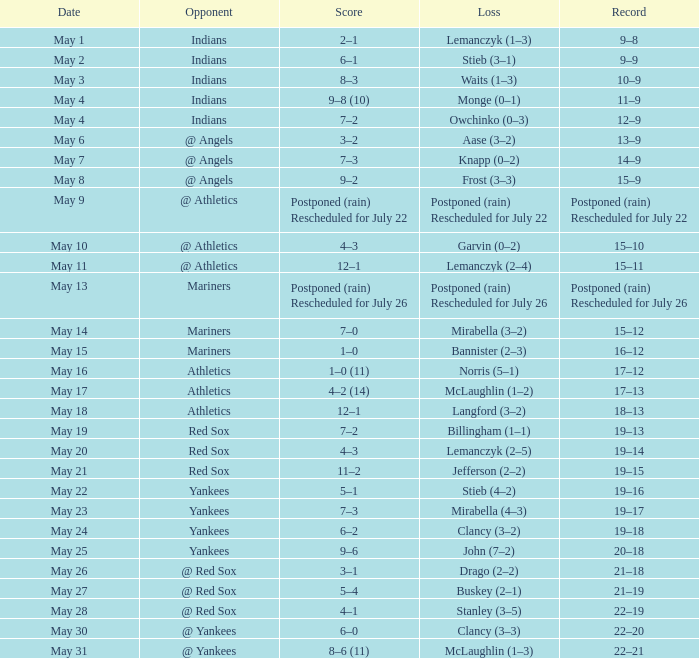Name the loss on may 22 Stieb (4–2). 